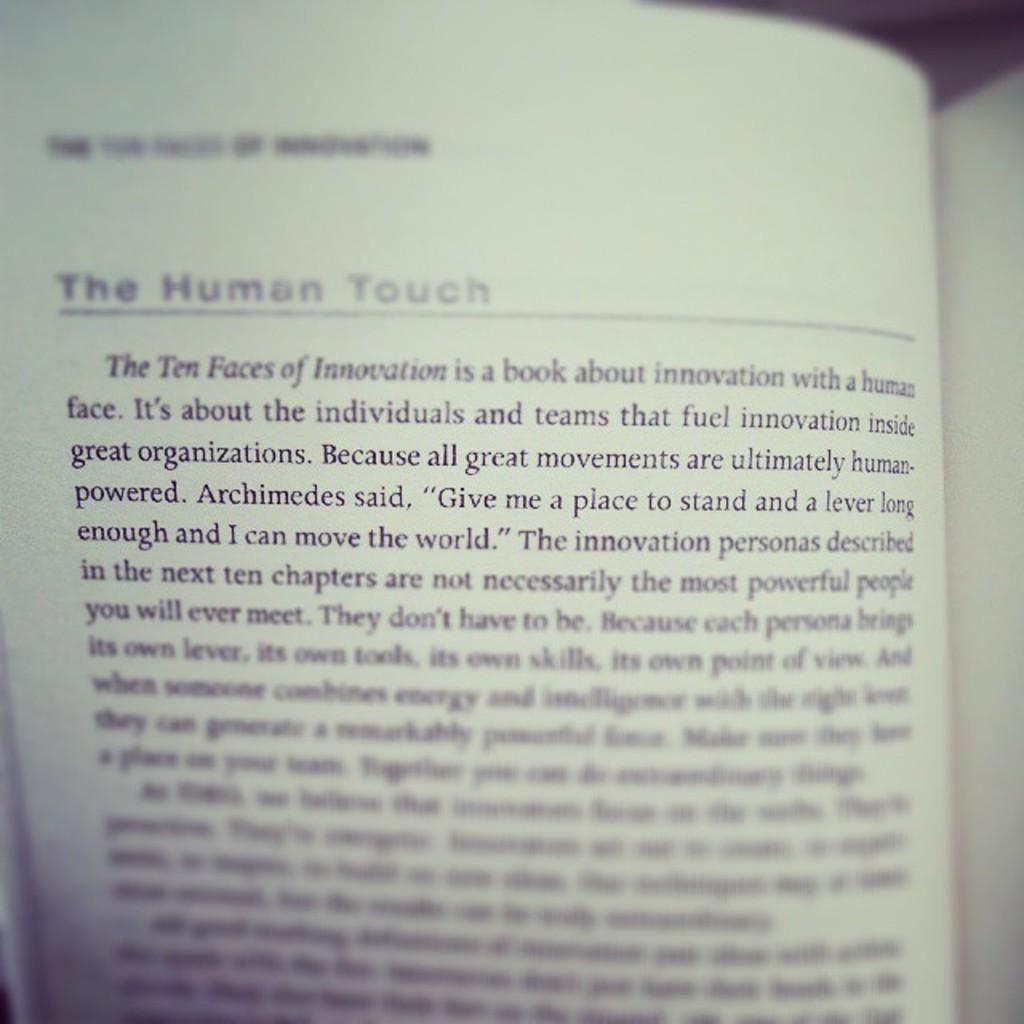<image>
Relay a brief, clear account of the picture shown. page from a book that is titled "The Human Touch". 